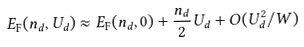<formula> <loc_0><loc_0><loc_500><loc_500>E _ { \text {F} } ( n _ { d } , U _ { d } ) \approx E _ { \text {F} } ( n _ { d } , 0 ) + \frac { n _ { d } } { 2 } U _ { d } + O ( U _ { d } ^ { 2 } / W )</formula> 